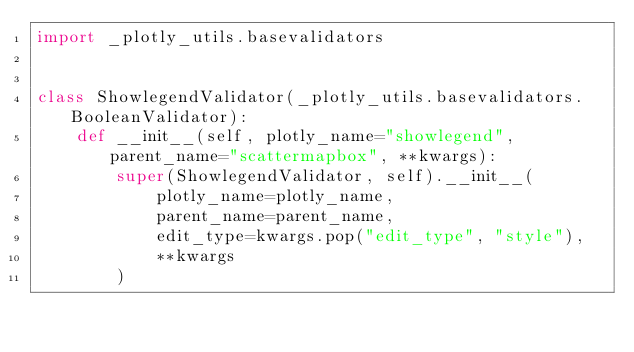<code> <loc_0><loc_0><loc_500><loc_500><_Python_>import _plotly_utils.basevalidators


class ShowlegendValidator(_plotly_utils.basevalidators.BooleanValidator):
    def __init__(self, plotly_name="showlegend", parent_name="scattermapbox", **kwargs):
        super(ShowlegendValidator, self).__init__(
            plotly_name=plotly_name,
            parent_name=parent_name,
            edit_type=kwargs.pop("edit_type", "style"),
            **kwargs
        )
</code> 